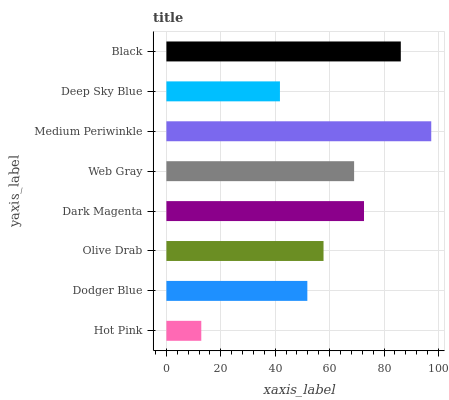Is Hot Pink the minimum?
Answer yes or no. Yes. Is Medium Periwinkle the maximum?
Answer yes or no. Yes. Is Dodger Blue the minimum?
Answer yes or no. No. Is Dodger Blue the maximum?
Answer yes or no. No. Is Dodger Blue greater than Hot Pink?
Answer yes or no. Yes. Is Hot Pink less than Dodger Blue?
Answer yes or no. Yes. Is Hot Pink greater than Dodger Blue?
Answer yes or no. No. Is Dodger Blue less than Hot Pink?
Answer yes or no. No. Is Web Gray the high median?
Answer yes or no. Yes. Is Olive Drab the low median?
Answer yes or no. Yes. Is Hot Pink the high median?
Answer yes or no. No. Is Web Gray the low median?
Answer yes or no. No. 